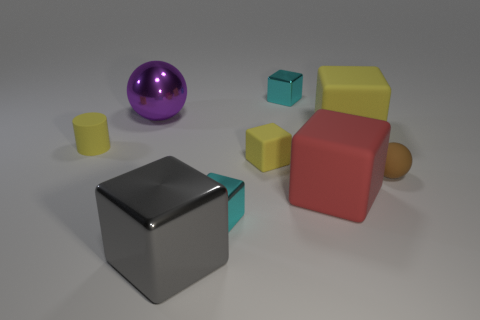Subtract all yellow cubes. How many cubes are left? 4 Subtract all tiny yellow matte blocks. How many blocks are left? 5 Subtract all gray cubes. Subtract all brown cylinders. How many cubes are left? 5 Add 1 small gray rubber cylinders. How many objects exist? 10 Subtract all cylinders. How many objects are left? 8 Add 4 metallic spheres. How many metallic spheres are left? 5 Add 8 tiny balls. How many tiny balls exist? 9 Subtract 0 red spheres. How many objects are left? 9 Subtract all purple matte things. Subtract all purple things. How many objects are left? 8 